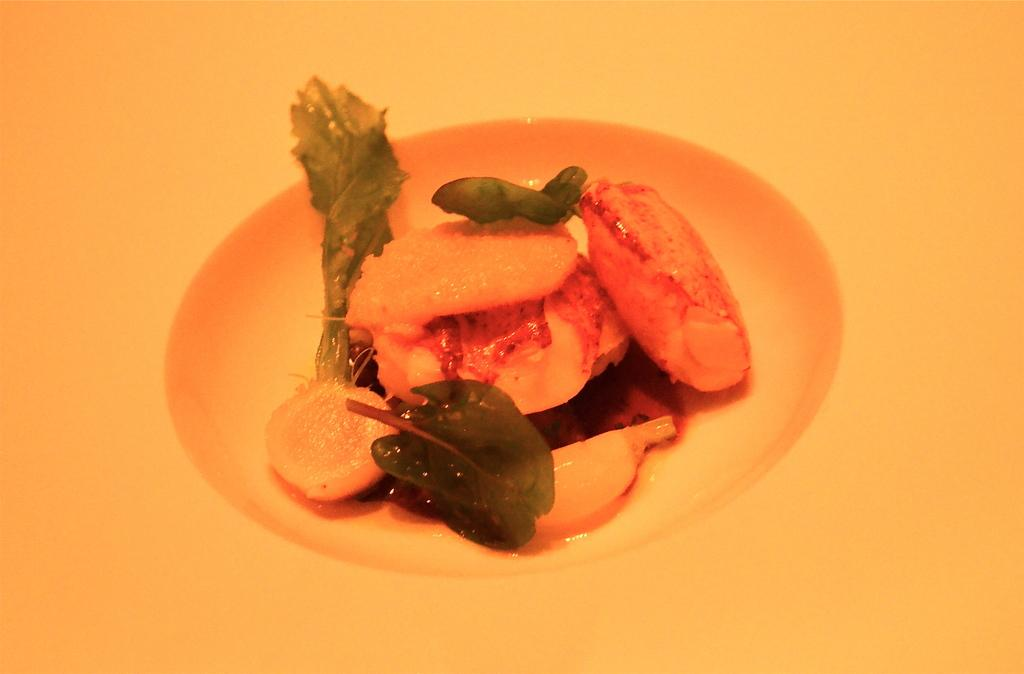What is located at the bottom of the image? There is a table at the bottom of the image. What is placed on the table? There is a plate on the table. What is in the plate? There is food in the plate. What type of bean is being read by the man in the image? There is no man or bean present in the image; it only features a table, a plate, and food. 